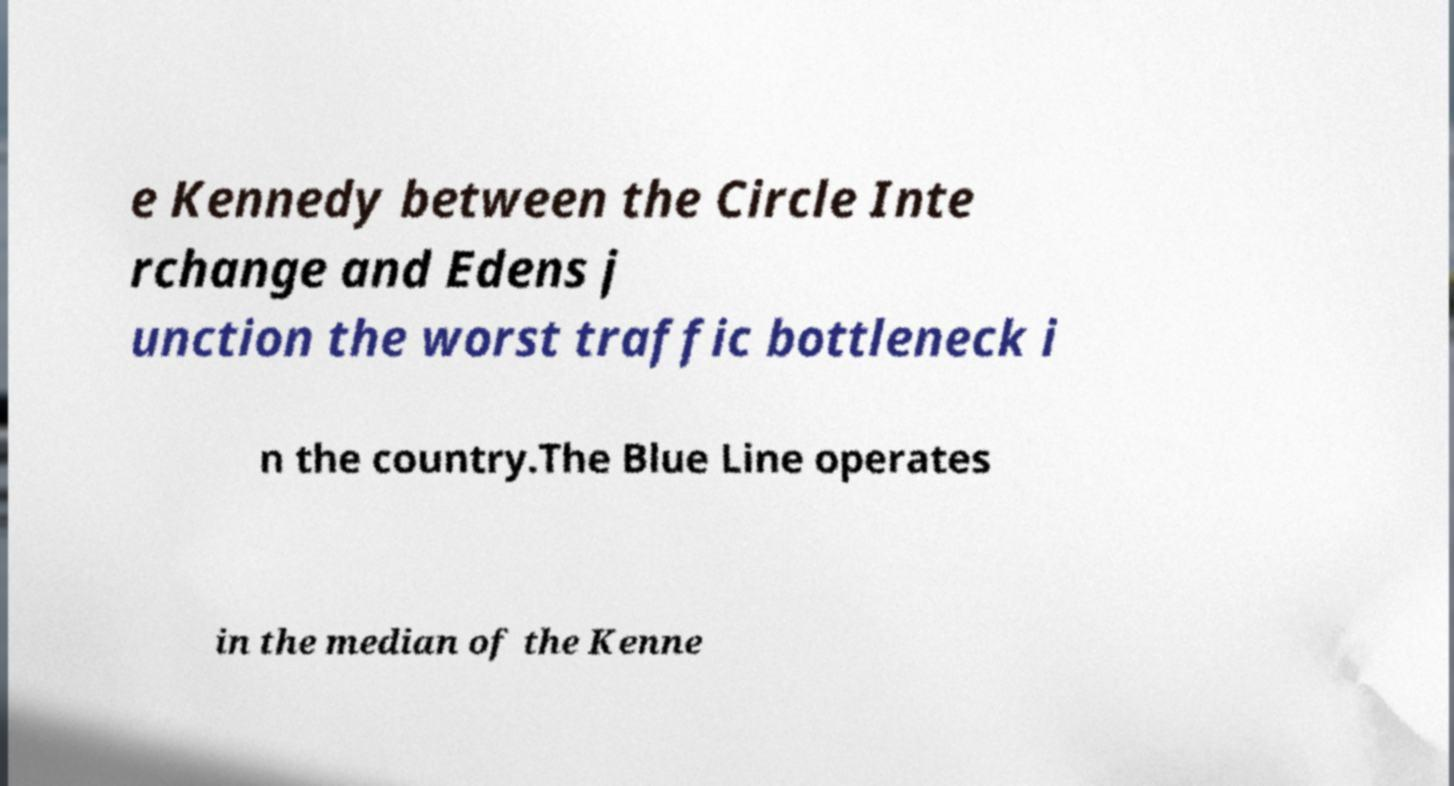Please identify and transcribe the text found in this image. e Kennedy between the Circle Inte rchange and Edens j unction the worst traffic bottleneck i n the country.The Blue Line operates in the median of the Kenne 